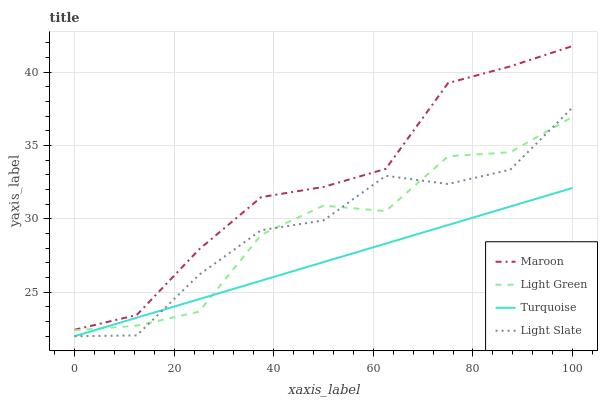Does Turquoise have the minimum area under the curve?
Answer yes or no. Yes. Does Maroon have the maximum area under the curve?
Answer yes or no. Yes. Does Light Green have the minimum area under the curve?
Answer yes or no. No. Does Light Green have the maximum area under the curve?
Answer yes or no. No. Is Turquoise the smoothest?
Answer yes or no. Yes. Is Light Green the roughest?
Answer yes or no. Yes. Is Light Green the smoothest?
Answer yes or no. No. Is Turquoise the roughest?
Answer yes or no. No. Does Light Green have the lowest value?
Answer yes or no. No. Does Maroon have the highest value?
Answer yes or no. Yes. Does Light Green have the highest value?
Answer yes or no. No. Is Light Slate less than Maroon?
Answer yes or no. Yes. Is Maroon greater than Light Slate?
Answer yes or no. Yes. Does Light Slate intersect Turquoise?
Answer yes or no. Yes. Is Light Slate less than Turquoise?
Answer yes or no. No. Is Light Slate greater than Turquoise?
Answer yes or no. No. Does Light Slate intersect Maroon?
Answer yes or no. No. 